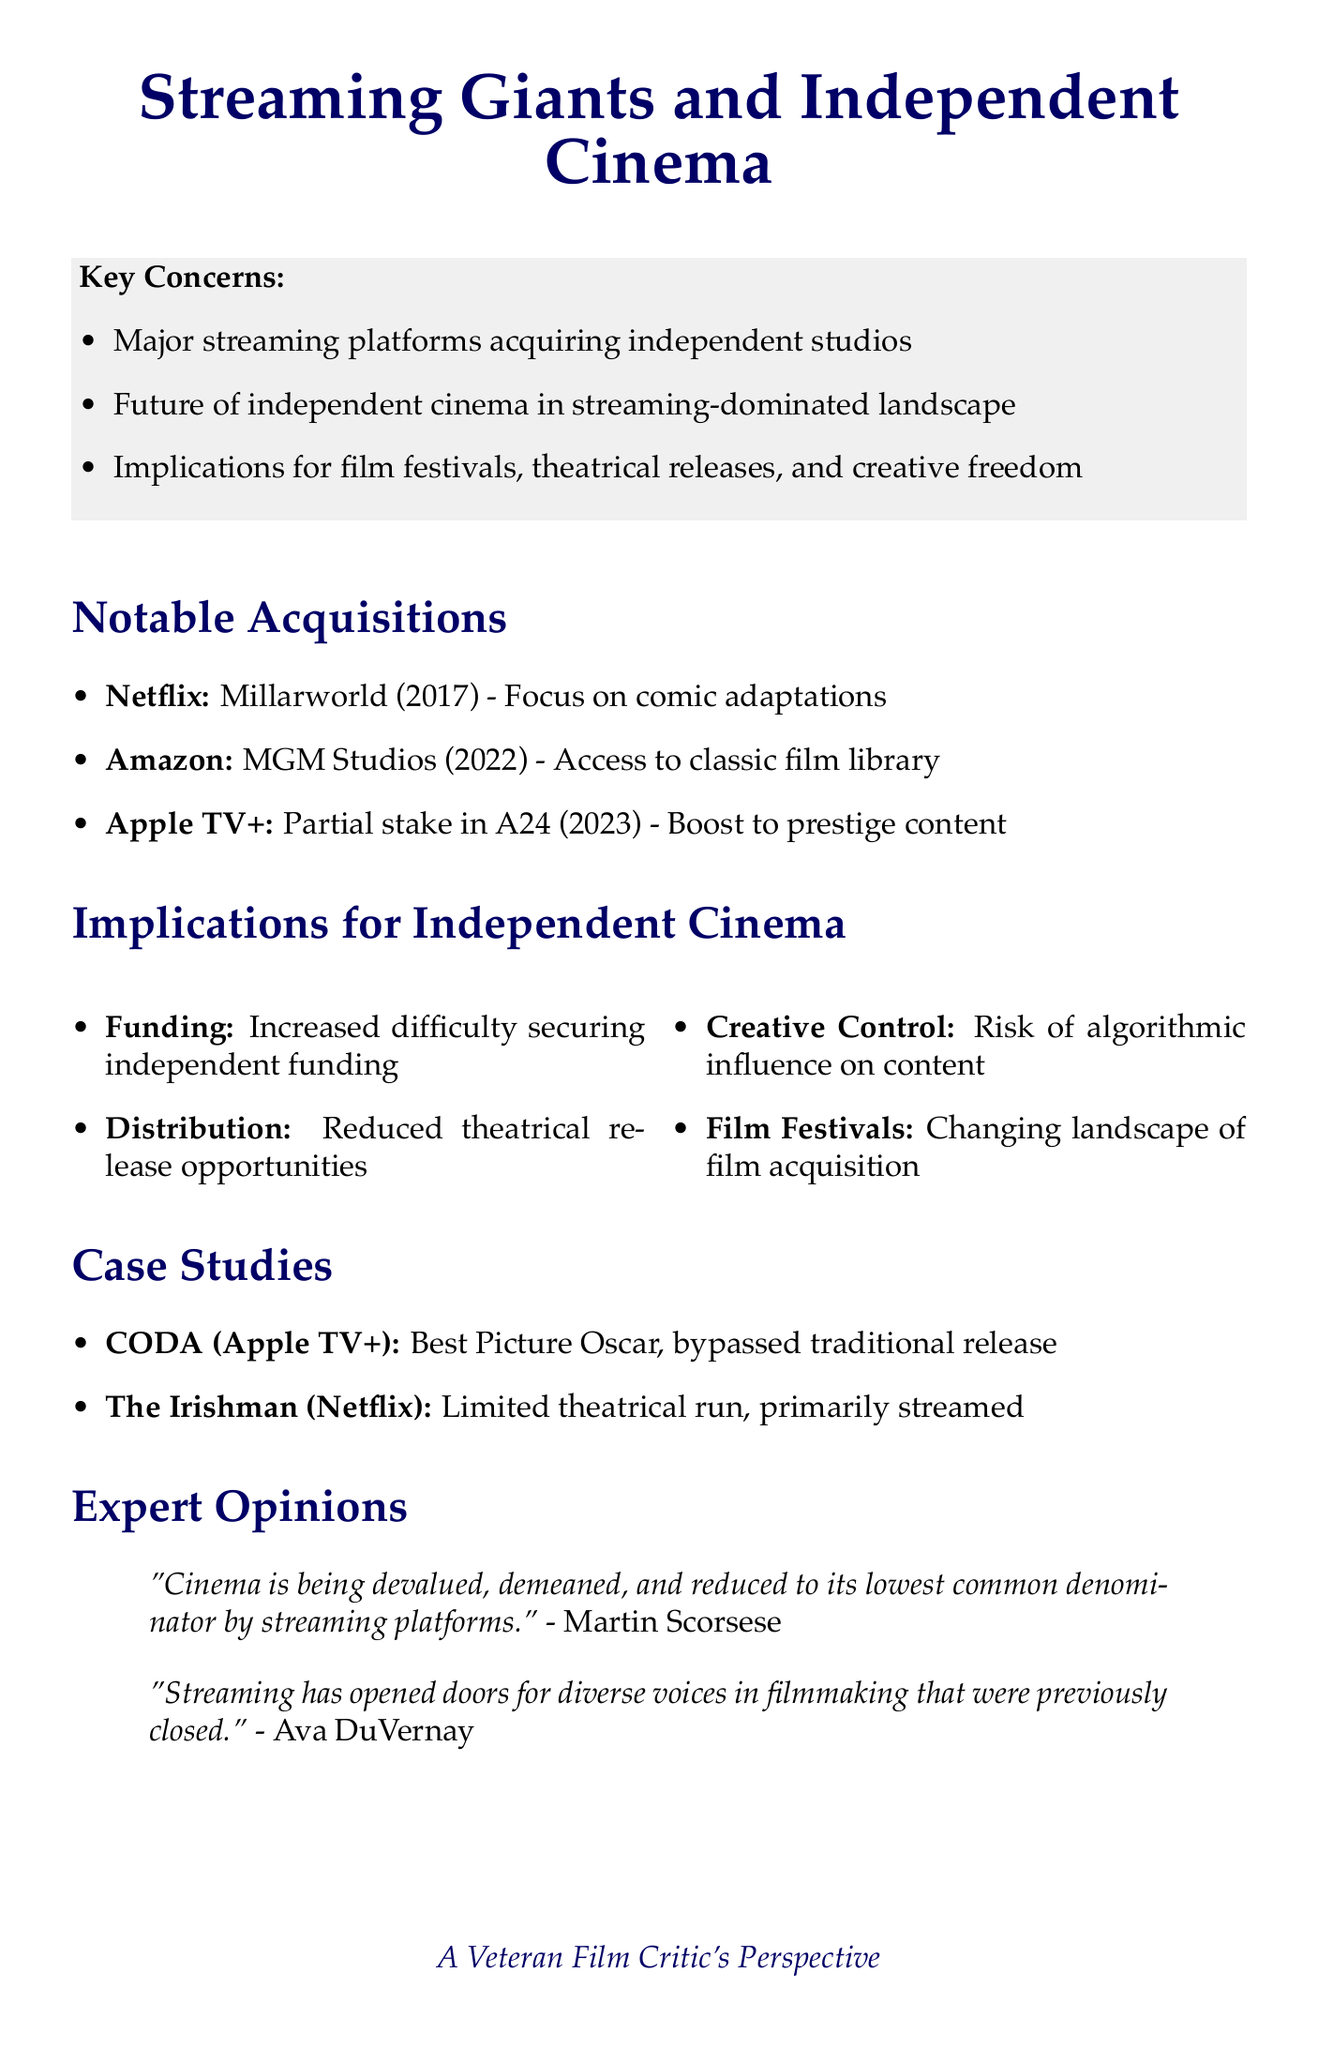What acquisition did Netflix make in 2017? The document states that Netflix acquired Millarworld in 2017.
Answer: Millarworld What year did Amazon acquire MGM Studios? According to the document, Amazon's acquisition of MGM Studios occurred in 2022.
Answer: 2022 What potential impact does the acquisition of A24 by Apple TV+ have? The memo mentions that it boosts prestige indie content and potential Oscar contenders.
Answer: Boost to prestige indie content and potential Oscar contenders Who stated that "cinema is being devalued" by streaming platforms? The document references a quote from Martin Scorsese about the devaluation of cinema.
Answer: Martin Scorsese What is one proposed solution to support independent cinema? The document lists several potential solutions, one of which is increased government funding for independent film production.
Answer: Increased government funding for independent film production What outcome did the film CODA achieve? The document indicates that CODA won the Best Picture Oscar.
Answer: Won Best Picture Oscar How have streaming acquisitions changed the landscape of film festivals? The memo notes a changing landscape of film acquisition at major festivals like Sundance and Cannes.
Answer: Changing landscape of film acquisition What challenge do independent filmmakers face in terms of funding? The document analyzes that there is increased difficulty for truly independent filmmakers to secure funding.
Answer: Increased difficulty securing funding How does streaming impact theatrical releases according to the memo? The analysis indicates reduced opportunities for theatrical releases, potentially limiting audience reach.
Answer: Reduced opportunities for theatrical releases 